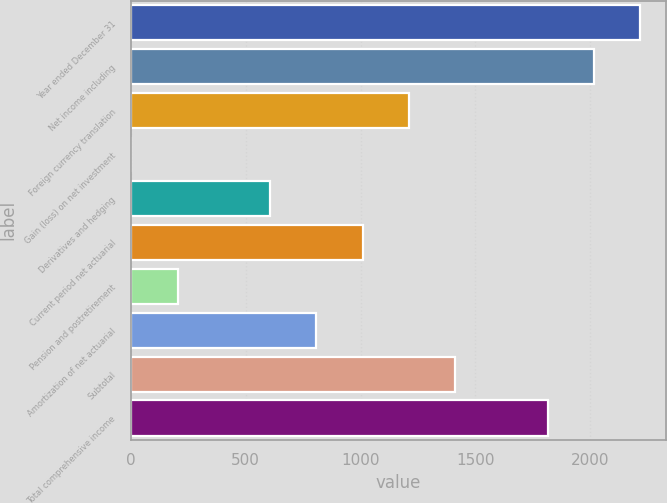Convert chart to OTSL. <chart><loc_0><loc_0><loc_500><loc_500><bar_chart><fcel>Year ended December 31<fcel>Net income including<fcel>Foreign currency translation<fcel>Gain (loss) on net investment<fcel>Derivatives and hedging<fcel>Current period net actuarial<fcel>Pension and postretirement<fcel>Amortization of net actuarial<fcel>Subtotal<fcel>Total comprehensive income<nl><fcel>2217.35<fcel>2016<fcel>1210.6<fcel>2.5<fcel>606.55<fcel>1009.25<fcel>203.85<fcel>807.9<fcel>1411.95<fcel>1814.65<nl></chart> 